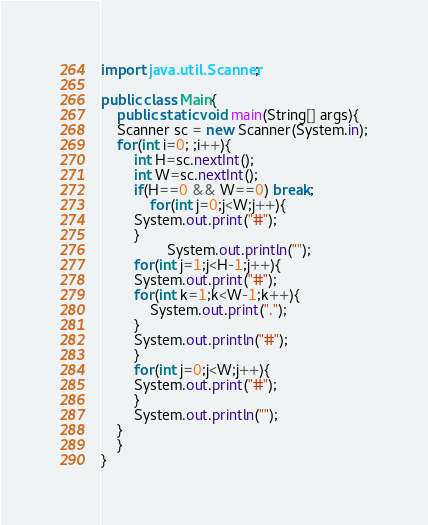<code> <loc_0><loc_0><loc_500><loc_500><_Java_>import java.util.Scanner;

public class Main{
    public static void main(String[] args){
	Scanner sc = new Scanner(System.in);
	for(int i=0; ;i++){
	    int H=sc.nextInt();
	    int W=sc.nextInt();
	    if(H==0 && W==0) break;
            for(int j=0;j<W;j++){
		System.out.print("#");
	    }
                System.out.println("");
	    for(int j=1;j<H-1;j++){
		System.out.print("#");
		for(int k=1;k<W-1;k++){
		    System.out.print(".");
		}
		System.out.println("#");
	    }
	    for(int j=0;j<W;j++){
		System.out.print("#");
	    }
	    System.out.println("");
	}
    }
}

</code> 